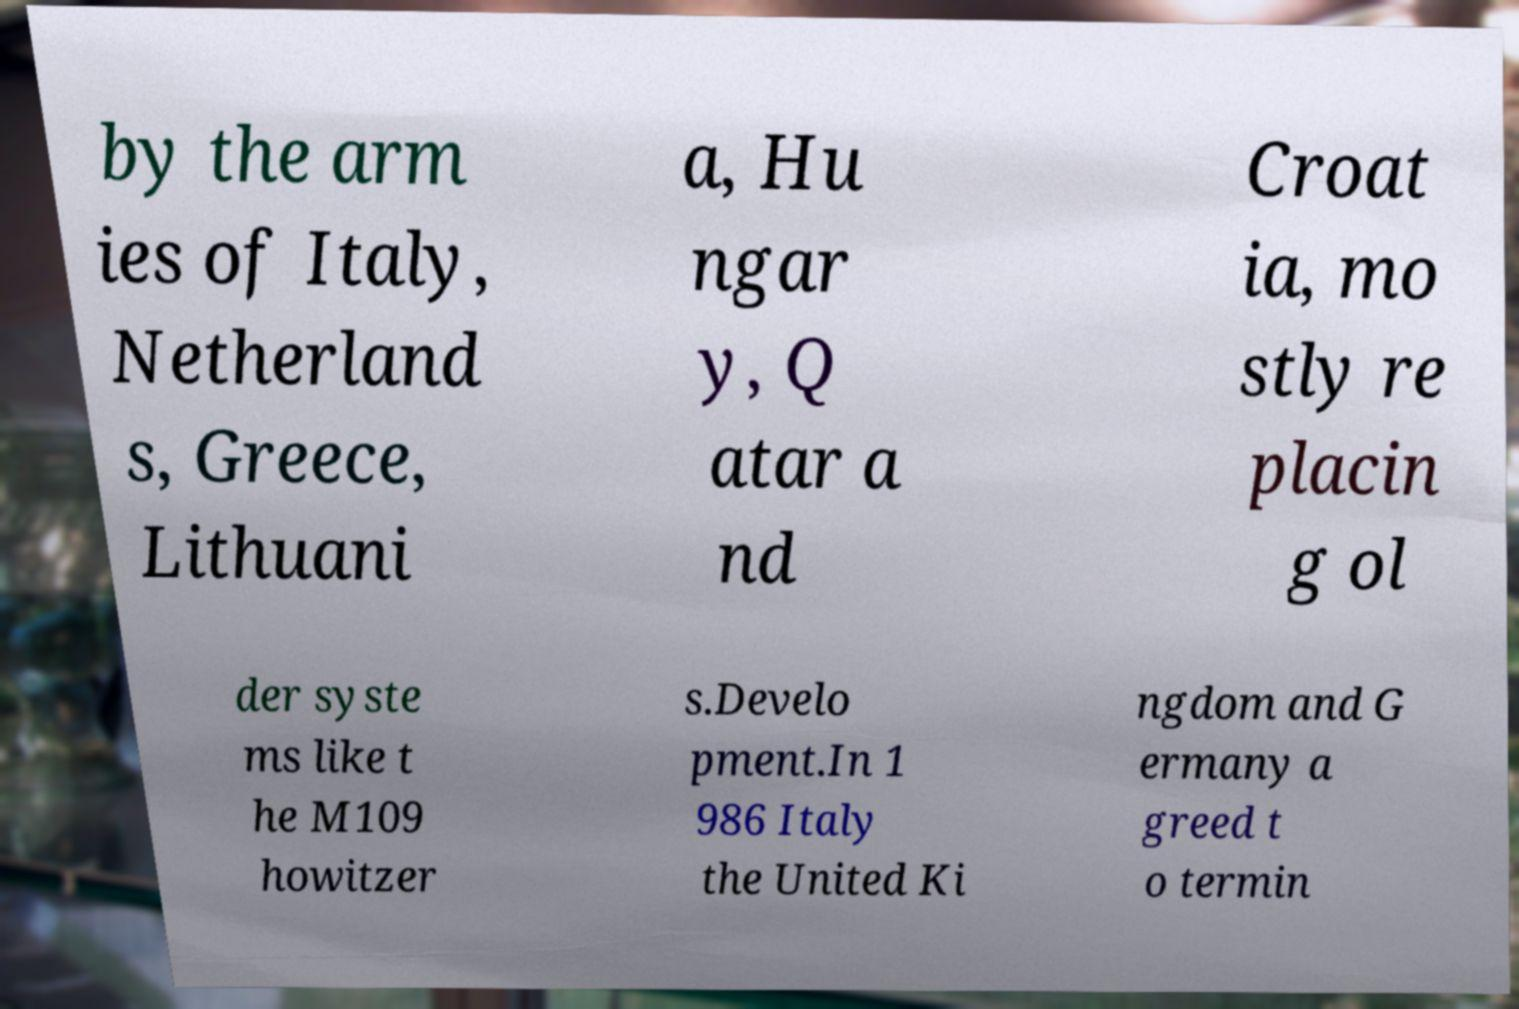Could you extract and type out the text from this image? by the arm ies of Italy, Netherland s, Greece, Lithuani a, Hu ngar y, Q atar a nd Croat ia, mo stly re placin g ol der syste ms like t he M109 howitzer s.Develo pment.In 1 986 Italy the United Ki ngdom and G ermany a greed t o termin 